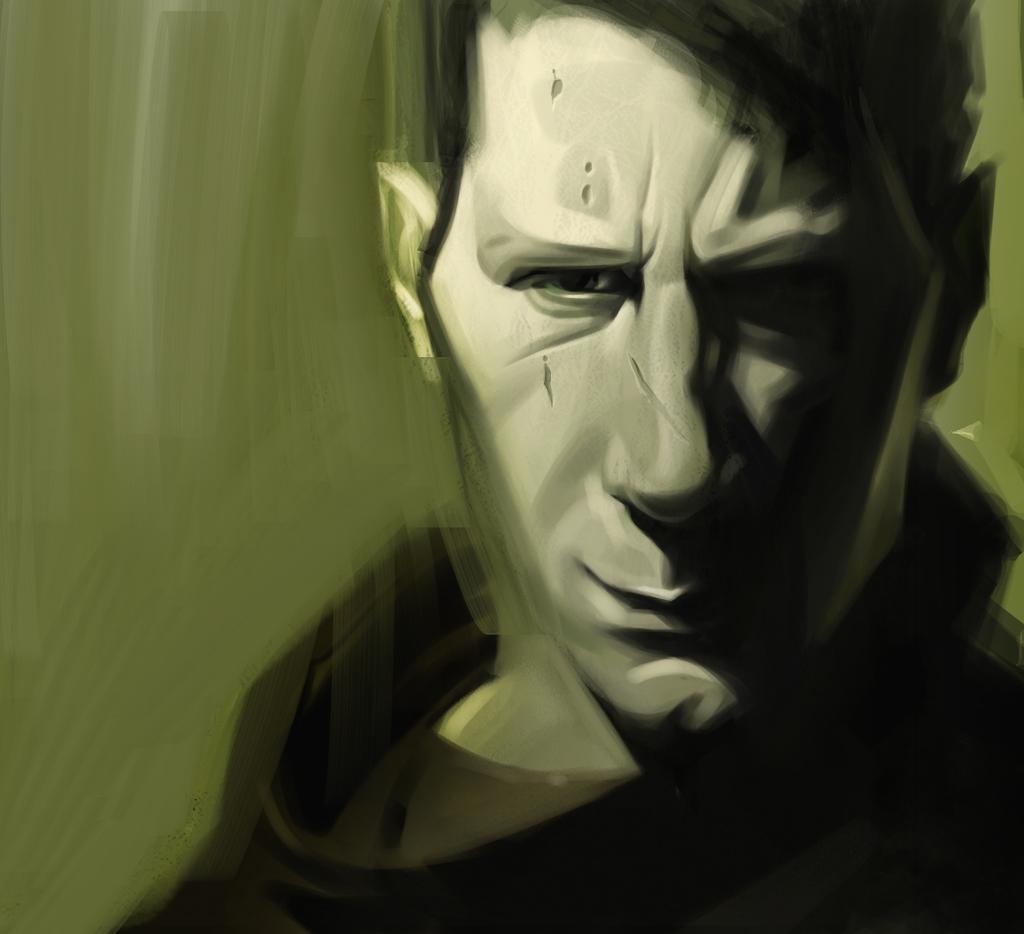Describe this image in one or two sentences. This is an edited image. In this image I can see a person. The background is blurred. 